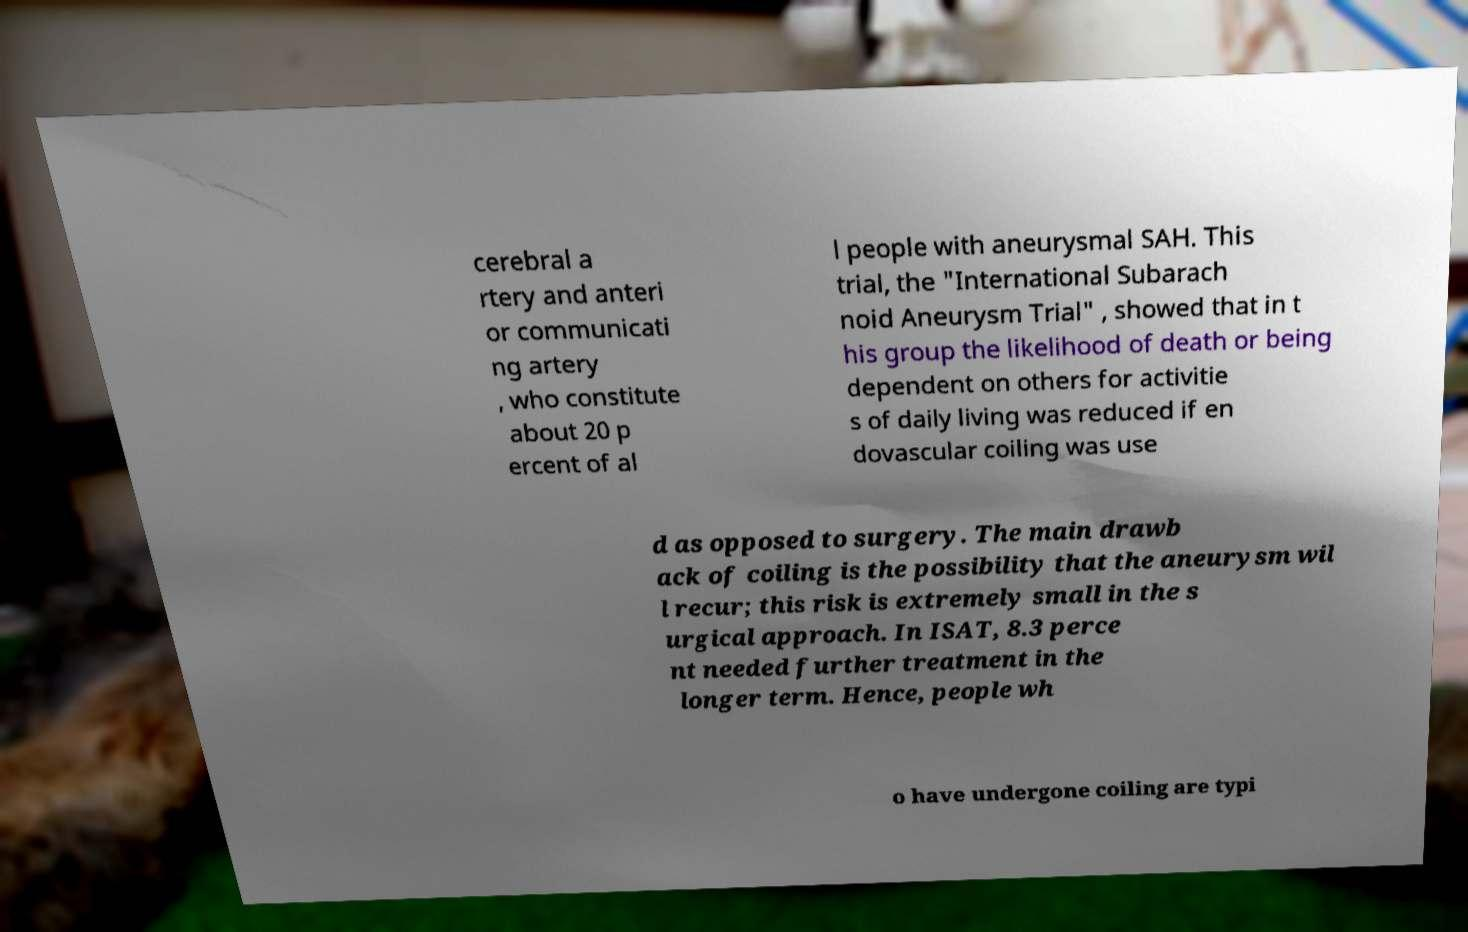I need the written content from this picture converted into text. Can you do that? cerebral a rtery and anteri or communicati ng artery , who constitute about 20 p ercent of al l people with aneurysmal SAH. This trial, the "International Subarach noid Aneurysm Trial" , showed that in t his group the likelihood of death or being dependent on others for activitie s of daily living was reduced if en dovascular coiling was use d as opposed to surgery. The main drawb ack of coiling is the possibility that the aneurysm wil l recur; this risk is extremely small in the s urgical approach. In ISAT, 8.3 perce nt needed further treatment in the longer term. Hence, people wh o have undergone coiling are typi 